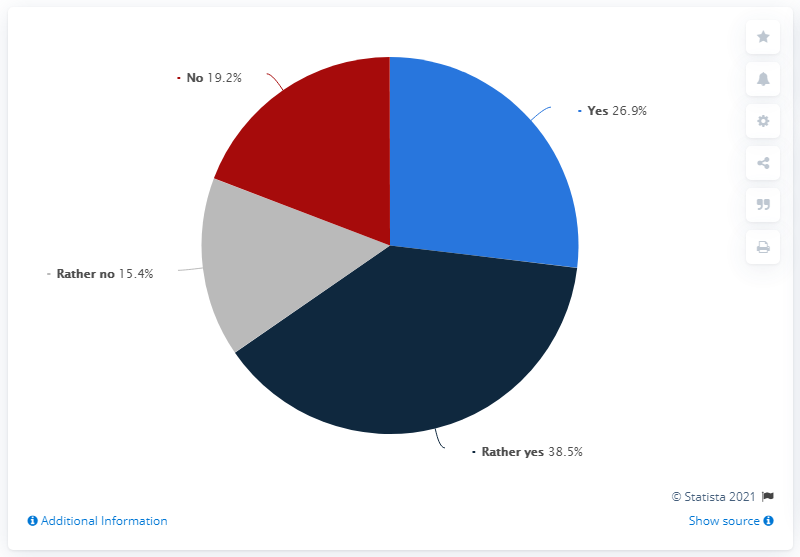Point out several critical features in this image. Yes is the leading response in this situation. The sum of negative responses is approximately 34.6.. 